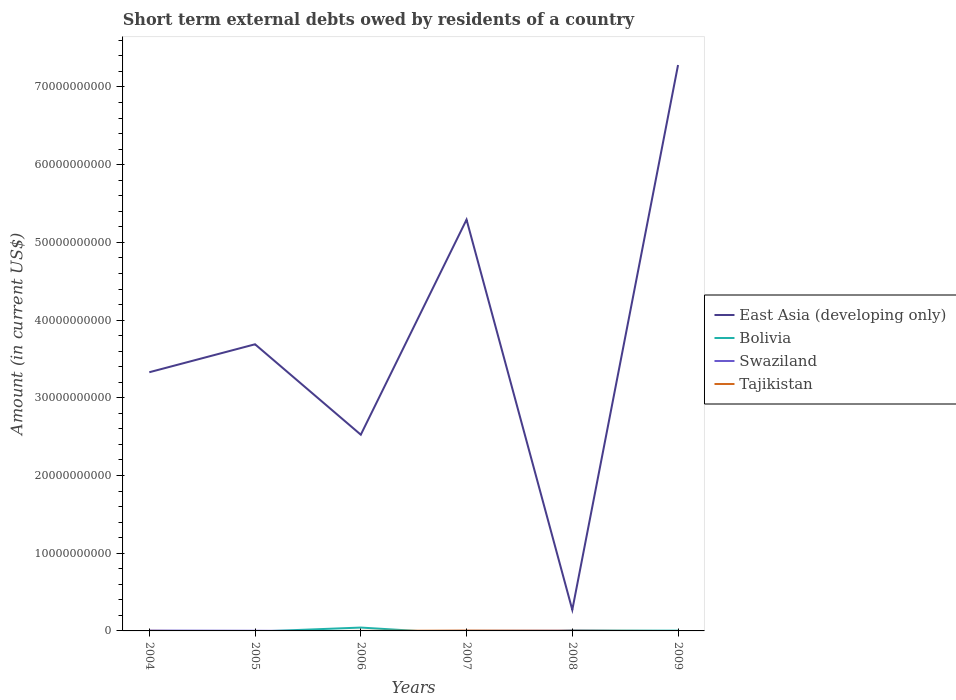What is the total amount of short-term external debts owed by residents in East Asia (developing only) in the graph?
Keep it short and to the point. -4.76e+1. What is the difference between the highest and the second highest amount of short-term external debts owed by residents in Tajikistan?
Make the answer very short. 4.32e+07. What is the difference between the highest and the lowest amount of short-term external debts owed by residents in East Asia (developing only)?
Provide a succinct answer. 2. Is the amount of short-term external debts owed by residents in East Asia (developing only) strictly greater than the amount of short-term external debts owed by residents in Tajikistan over the years?
Offer a terse response. No. How many years are there in the graph?
Provide a short and direct response. 6. Are the values on the major ticks of Y-axis written in scientific E-notation?
Your response must be concise. No. Where does the legend appear in the graph?
Provide a short and direct response. Center right. How many legend labels are there?
Your response must be concise. 4. How are the legend labels stacked?
Keep it short and to the point. Vertical. What is the title of the graph?
Your response must be concise. Short term external debts owed by residents of a country. Does "Dominica" appear as one of the legend labels in the graph?
Offer a very short reply. No. What is the Amount (in current US$) of East Asia (developing only) in 2004?
Ensure brevity in your answer.  3.33e+1. What is the Amount (in current US$) of Swaziland in 2004?
Your answer should be compact. 4.37e+07. What is the Amount (in current US$) of East Asia (developing only) in 2005?
Offer a very short reply. 3.69e+1. What is the Amount (in current US$) in Bolivia in 2005?
Give a very brief answer. 0. What is the Amount (in current US$) in Swaziland in 2005?
Offer a terse response. 2.10e+07. What is the Amount (in current US$) of East Asia (developing only) in 2006?
Ensure brevity in your answer.  2.53e+1. What is the Amount (in current US$) in Bolivia in 2006?
Offer a terse response. 4.33e+08. What is the Amount (in current US$) in Swaziland in 2006?
Your answer should be compact. 0. What is the Amount (in current US$) in Tajikistan in 2006?
Keep it short and to the point. 3.80e+06. What is the Amount (in current US$) of East Asia (developing only) in 2007?
Your response must be concise. 5.29e+1. What is the Amount (in current US$) of Bolivia in 2007?
Provide a short and direct response. 0. What is the Amount (in current US$) of Swaziland in 2007?
Ensure brevity in your answer.  0. What is the Amount (in current US$) in Tajikistan in 2007?
Your answer should be very brief. 4.32e+07. What is the Amount (in current US$) in East Asia (developing only) in 2008?
Make the answer very short. 2.72e+09. What is the Amount (in current US$) in Bolivia in 2008?
Provide a short and direct response. 4.70e+07. What is the Amount (in current US$) in Swaziland in 2008?
Offer a very short reply. 2.70e+07. What is the Amount (in current US$) in Tajikistan in 2008?
Keep it short and to the point. 1.77e+07. What is the Amount (in current US$) in East Asia (developing only) in 2009?
Your response must be concise. 7.28e+1. What is the Amount (in current US$) of Bolivia in 2009?
Give a very brief answer. 3.44e+07. What is the Amount (in current US$) in Swaziland in 2009?
Keep it short and to the point. 0. What is the Amount (in current US$) in Tajikistan in 2009?
Your answer should be very brief. 0. Across all years, what is the maximum Amount (in current US$) in East Asia (developing only)?
Offer a very short reply. 7.28e+1. Across all years, what is the maximum Amount (in current US$) of Bolivia?
Offer a very short reply. 4.33e+08. Across all years, what is the maximum Amount (in current US$) of Swaziland?
Give a very brief answer. 4.37e+07. Across all years, what is the maximum Amount (in current US$) of Tajikistan?
Provide a short and direct response. 4.32e+07. Across all years, what is the minimum Amount (in current US$) of East Asia (developing only)?
Provide a short and direct response. 2.72e+09. Across all years, what is the minimum Amount (in current US$) of Swaziland?
Your answer should be very brief. 0. Across all years, what is the minimum Amount (in current US$) of Tajikistan?
Your answer should be compact. 0. What is the total Amount (in current US$) of East Asia (developing only) in the graph?
Offer a very short reply. 2.24e+11. What is the total Amount (in current US$) in Bolivia in the graph?
Keep it short and to the point. 5.14e+08. What is the total Amount (in current US$) in Swaziland in the graph?
Give a very brief answer. 9.17e+07. What is the total Amount (in current US$) of Tajikistan in the graph?
Your answer should be very brief. 6.87e+07. What is the difference between the Amount (in current US$) of East Asia (developing only) in 2004 and that in 2005?
Provide a short and direct response. -3.60e+09. What is the difference between the Amount (in current US$) of Swaziland in 2004 and that in 2005?
Ensure brevity in your answer.  2.27e+07. What is the difference between the Amount (in current US$) in East Asia (developing only) in 2004 and that in 2006?
Keep it short and to the point. 8.04e+09. What is the difference between the Amount (in current US$) of East Asia (developing only) in 2004 and that in 2007?
Give a very brief answer. -1.96e+1. What is the difference between the Amount (in current US$) in Tajikistan in 2004 and that in 2007?
Your answer should be compact. -3.92e+07. What is the difference between the Amount (in current US$) of East Asia (developing only) in 2004 and that in 2008?
Offer a terse response. 3.06e+1. What is the difference between the Amount (in current US$) in Swaziland in 2004 and that in 2008?
Your response must be concise. 1.67e+07. What is the difference between the Amount (in current US$) in Tajikistan in 2004 and that in 2008?
Offer a very short reply. -1.37e+07. What is the difference between the Amount (in current US$) of East Asia (developing only) in 2004 and that in 2009?
Provide a short and direct response. -3.95e+1. What is the difference between the Amount (in current US$) in East Asia (developing only) in 2005 and that in 2006?
Ensure brevity in your answer.  1.16e+1. What is the difference between the Amount (in current US$) in East Asia (developing only) in 2005 and that in 2007?
Give a very brief answer. -1.60e+1. What is the difference between the Amount (in current US$) of East Asia (developing only) in 2005 and that in 2008?
Your answer should be very brief. 3.42e+1. What is the difference between the Amount (in current US$) of Swaziland in 2005 and that in 2008?
Your answer should be very brief. -6.00e+06. What is the difference between the Amount (in current US$) of East Asia (developing only) in 2005 and that in 2009?
Give a very brief answer. -3.59e+1. What is the difference between the Amount (in current US$) of East Asia (developing only) in 2006 and that in 2007?
Offer a very short reply. -2.77e+1. What is the difference between the Amount (in current US$) in Tajikistan in 2006 and that in 2007?
Give a very brief answer. -3.94e+07. What is the difference between the Amount (in current US$) in East Asia (developing only) in 2006 and that in 2008?
Your answer should be very brief. 2.25e+1. What is the difference between the Amount (in current US$) in Bolivia in 2006 and that in 2008?
Make the answer very short. 3.86e+08. What is the difference between the Amount (in current US$) of Tajikistan in 2006 and that in 2008?
Provide a short and direct response. -1.39e+07. What is the difference between the Amount (in current US$) in East Asia (developing only) in 2006 and that in 2009?
Offer a very short reply. -4.76e+1. What is the difference between the Amount (in current US$) in Bolivia in 2006 and that in 2009?
Ensure brevity in your answer.  3.99e+08. What is the difference between the Amount (in current US$) in East Asia (developing only) in 2007 and that in 2008?
Provide a succinct answer. 5.02e+1. What is the difference between the Amount (in current US$) in Tajikistan in 2007 and that in 2008?
Give a very brief answer. 2.55e+07. What is the difference between the Amount (in current US$) of East Asia (developing only) in 2007 and that in 2009?
Ensure brevity in your answer.  -1.99e+1. What is the difference between the Amount (in current US$) in East Asia (developing only) in 2008 and that in 2009?
Provide a succinct answer. -7.01e+1. What is the difference between the Amount (in current US$) in Bolivia in 2008 and that in 2009?
Your response must be concise. 1.27e+07. What is the difference between the Amount (in current US$) of East Asia (developing only) in 2004 and the Amount (in current US$) of Swaziland in 2005?
Your answer should be compact. 3.33e+1. What is the difference between the Amount (in current US$) in East Asia (developing only) in 2004 and the Amount (in current US$) in Bolivia in 2006?
Your response must be concise. 3.29e+1. What is the difference between the Amount (in current US$) of East Asia (developing only) in 2004 and the Amount (in current US$) of Tajikistan in 2006?
Your answer should be very brief. 3.33e+1. What is the difference between the Amount (in current US$) of Swaziland in 2004 and the Amount (in current US$) of Tajikistan in 2006?
Make the answer very short. 3.99e+07. What is the difference between the Amount (in current US$) of East Asia (developing only) in 2004 and the Amount (in current US$) of Tajikistan in 2007?
Your response must be concise. 3.32e+1. What is the difference between the Amount (in current US$) of Swaziland in 2004 and the Amount (in current US$) of Tajikistan in 2007?
Offer a very short reply. 5.22e+05. What is the difference between the Amount (in current US$) in East Asia (developing only) in 2004 and the Amount (in current US$) in Bolivia in 2008?
Offer a very short reply. 3.32e+1. What is the difference between the Amount (in current US$) of East Asia (developing only) in 2004 and the Amount (in current US$) of Swaziland in 2008?
Give a very brief answer. 3.33e+1. What is the difference between the Amount (in current US$) of East Asia (developing only) in 2004 and the Amount (in current US$) of Tajikistan in 2008?
Your response must be concise. 3.33e+1. What is the difference between the Amount (in current US$) of Swaziland in 2004 and the Amount (in current US$) of Tajikistan in 2008?
Your answer should be very brief. 2.60e+07. What is the difference between the Amount (in current US$) of East Asia (developing only) in 2004 and the Amount (in current US$) of Bolivia in 2009?
Make the answer very short. 3.33e+1. What is the difference between the Amount (in current US$) of East Asia (developing only) in 2005 and the Amount (in current US$) of Bolivia in 2006?
Offer a very short reply. 3.65e+1. What is the difference between the Amount (in current US$) of East Asia (developing only) in 2005 and the Amount (in current US$) of Tajikistan in 2006?
Your answer should be very brief. 3.69e+1. What is the difference between the Amount (in current US$) in Swaziland in 2005 and the Amount (in current US$) in Tajikistan in 2006?
Your answer should be compact. 1.72e+07. What is the difference between the Amount (in current US$) in East Asia (developing only) in 2005 and the Amount (in current US$) in Tajikistan in 2007?
Make the answer very short. 3.68e+1. What is the difference between the Amount (in current US$) in Swaziland in 2005 and the Amount (in current US$) in Tajikistan in 2007?
Offer a very short reply. -2.22e+07. What is the difference between the Amount (in current US$) of East Asia (developing only) in 2005 and the Amount (in current US$) of Bolivia in 2008?
Your response must be concise. 3.68e+1. What is the difference between the Amount (in current US$) of East Asia (developing only) in 2005 and the Amount (in current US$) of Swaziland in 2008?
Your answer should be very brief. 3.69e+1. What is the difference between the Amount (in current US$) of East Asia (developing only) in 2005 and the Amount (in current US$) of Tajikistan in 2008?
Offer a terse response. 3.69e+1. What is the difference between the Amount (in current US$) of Swaziland in 2005 and the Amount (in current US$) of Tajikistan in 2008?
Your response must be concise. 3.30e+06. What is the difference between the Amount (in current US$) of East Asia (developing only) in 2005 and the Amount (in current US$) of Bolivia in 2009?
Your response must be concise. 3.69e+1. What is the difference between the Amount (in current US$) in East Asia (developing only) in 2006 and the Amount (in current US$) in Tajikistan in 2007?
Your answer should be compact. 2.52e+1. What is the difference between the Amount (in current US$) in Bolivia in 2006 and the Amount (in current US$) in Tajikistan in 2007?
Keep it short and to the point. 3.90e+08. What is the difference between the Amount (in current US$) of East Asia (developing only) in 2006 and the Amount (in current US$) of Bolivia in 2008?
Ensure brevity in your answer.  2.52e+1. What is the difference between the Amount (in current US$) in East Asia (developing only) in 2006 and the Amount (in current US$) in Swaziland in 2008?
Your answer should be compact. 2.52e+1. What is the difference between the Amount (in current US$) of East Asia (developing only) in 2006 and the Amount (in current US$) of Tajikistan in 2008?
Provide a succinct answer. 2.52e+1. What is the difference between the Amount (in current US$) in Bolivia in 2006 and the Amount (in current US$) in Swaziland in 2008?
Offer a terse response. 4.06e+08. What is the difference between the Amount (in current US$) of Bolivia in 2006 and the Amount (in current US$) of Tajikistan in 2008?
Your answer should be very brief. 4.15e+08. What is the difference between the Amount (in current US$) in East Asia (developing only) in 2006 and the Amount (in current US$) in Bolivia in 2009?
Offer a very short reply. 2.52e+1. What is the difference between the Amount (in current US$) in East Asia (developing only) in 2007 and the Amount (in current US$) in Bolivia in 2008?
Your answer should be very brief. 5.29e+1. What is the difference between the Amount (in current US$) in East Asia (developing only) in 2007 and the Amount (in current US$) in Swaziland in 2008?
Give a very brief answer. 5.29e+1. What is the difference between the Amount (in current US$) in East Asia (developing only) in 2007 and the Amount (in current US$) in Tajikistan in 2008?
Your answer should be compact. 5.29e+1. What is the difference between the Amount (in current US$) in East Asia (developing only) in 2007 and the Amount (in current US$) in Bolivia in 2009?
Your answer should be very brief. 5.29e+1. What is the difference between the Amount (in current US$) in East Asia (developing only) in 2008 and the Amount (in current US$) in Bolivia in 2009?
Your answer should be compact. 2.68e+09. What is the average Amount (in current US$) in East Asia (developing only) per year?
Your answer should be very brief. 3.73e+1. What is the average Amount (in current US$) of Bolivia per year?
Make the answer very short. 8.57e+07. What is the average Amount (in current US$) of Swaziland per year?
Your response must be concise. 1.53e+07. What is the average Amount (in current US$) in Tajikistan per year?
Make the answer very short. 1.14e+07. In the year 2004, what is the difference between the Amount (in current US$) in East Asia (developing only) and Amount (in current US$) in Swaziland?
Offer a terse response. 3.32e+1. In the year 2004, what is the difference between the Amount (in current US$) of East Asia (developing only) and Amount (in current US$) of Tajikistan?
Provide a succinct answer. 3.33e+1. In the year 2004, what is the difference between the Amount (in current US$) in Swaziland and Amount (in current US$) in Tajikistan?
Provide a succinct answer. 3.97e+07. In the year 2005, what is the difference between the Amount (in current US$) of East Asia (developing only) and Amount (in current US$) of Swaziland?
Offer a terse response. 3.69e+1. In the year 2006, what is the difference between the Amount (in current US$) in East Asia (developing only) and Amount (in current US$) in Bolivia?
Keep it short and to the point. 2.48e+1. In the year 2006, what is the difference between the Amount (in current US$) of East Asia (developing only) and Amount (in current US$) of Tajikistan?
Your response must be concise. 2.52e+1. In the year 2006, what is the difference between the Amount (in current US$) of Bolivia and Amount (in current US$) of Tajikistan?
Ensure brevity in your answer.  4.29e+08. In the year 2007, what is the difference between the Amount (in current US$) of East Asia (developing only) and Amount (in current US$) of Tajikistan?
Offer a terse response. 5.29e+1. In the year 2008, what is the difference between the Amount (in current US$) of East Asia (developing only) and Amount (in current US$) of Bolivia?
Keep it short and to the point. 2.67e+09. In the year 2008, what is the difference between the Amount (in current US$) in East Asia (developing only) and Amount (in current US$) in Swaziland?
Keep it short and to the point. 2.69e+09. In the year 2008, what is the difference between the Amount (in current US$) in East Asia (developing only) and Amount (in current US$) in Tajikistan?
Ensure brevity in your answer.  2.70e+09. In the year 2008, what is the difference between the Amount (in current US$) of Bolivia and Amount (in current US$) of Swaziland?
Offer a very short reply. 2.00e+07. In the year 2008, what is the difference between the Amount (in current US$) of Bolivia and Amount (in current US$) of Tajikistan?
Your answer should be compact. 2.93e+07. In the year 2008, what is the difference between the Amount (in current US$) in Swaziland and Amount (in current US$) in Tajikistan?
Offer a very short reply. 9.30e+06. In the year 2009, what is the difference between the Amount (in current US$) in East Asia (developing only) and Amount (in current US$) in Bolivia?
Provide a succinct answer. 7.28e+1. What is the ratio of the Amount (in current US$) of East Asia (developing only) in 2004 to that in 2005?
Make the answer very short. 0.9. What is the ratio of the Amount (in current US$) of Swaziland in 2004 to that in 2005?
Offer a very short reply. 2.08. What is the ratio of the Amount (in current US$) of East Asia (developing only) in 2004 to that in 2006?
Provide a short and direct response. 1.32. What is the ratio of the Amount (in current US$) in Tajikistan in 2004 to that in 2006?
Your response must be concise. 1.05. What is the ratio of the Amount (in current US$) of East Asia (developing only) in 2004 to that in 2007?
Your answer should be very brief. 0.63. What is the ratio of the Amount (in current US$) in Tajikistan in 2004 to that in 2007?
Your response must be concise. 0.09. What is the ratio of the Amount (in current US$) of East Asia (developing only) in 2004 to that in 2008?
Provide a short and direct response. 12.26. What is the ratio of the Amount (in current US$) of Swaziland in 2004 to that in 2008?
Your answer should be compact. 1.62. What is the ratio of the Amount (in current US$) of Tajikistan in 2004 to that in 2008?
Keep it short and to the point. 0.23. What is the ratio of the Amount (in current US$) in East Asia (developing only) in 2004 to that in 2009?
Your answer should be compact. 0.46. What is the ratio of the Amount (in current US$) in East Asia (developing only) in 2005 to that in 2006?
Provide a short and direct response. 1.46. What is the ratio of the Amount (in current US$) of East Asia (developing only) in 2005 to that in 2007?
Your answer should be very brief. 0.7. What is the ratio of the Amount (in current US$) of East Asia (developing only) in 2005 to that in 2008?
Make the answer very short. 13.59. What is the ratio of the Amount (in current US$) of Swaziland in 2005 to that in 2008?
Your answer should be compact. 0.78. What is the ratio of the Amount (in current US$) in East Asia (developing only) in 2005 to that in 2009?
Offer a very short reply. 0.51. What is the ratio of the Amount (in current US$) of East Asia (developing only) in 2006 to that in 2007?
Provide a succinct answer. 0.48. What is the ratio of the Amount (in current US$) in Tajikistan in 2006 to that in 2007?
Offer a very short reply. 0.09. What is the ratio of the Amount (in current US$) in East Asia (developing only) in 2006 to that in 2008?
Your answer should be very brief. 9.3. What is the ratio of the Amount (in current US$) in Bolivia in 2006 to that in 2008?
Give a very brief answer. 9.21. What is the ratio of the Amount (in current US$) in Tajikistan in 2006 to that in 2008?
Make the answer very short. 0.21. What is the ratio of the Amount (in current US$) in East Asia (developing only) in 2006 to that in 2009?
Give a very brief answer. 0.35. What is the ratio of the Amount (in current US$) of Bolivia in 2006 to that in 2009?
Offer a terse response. 12.6. What is the ratio of the Amount (in current US$) in East Asia (developing only) in 2007 to that in 2008?
Your answer should be compact. 19.49. What is the ratio of the Amount (in current US$) of Tajikistan in 2007 to that in 2008?
Provide a succinct answer. 2.44. What is the ratio of the Amount (in current US$) of East Asia (developing only) in 2007 to that in 2009?
Offer a very short reply. 0.73. What is the ratio of the Amount (in current US$) of East Asia (developing only) in 2008 to that in 2009?
Your answer should be very brief. 0.04. What is the ratio of the Amount (in current US$) in Bolivia in 2008 to that in 2009?
Your answer should be compact. 1.37. What is the difference between the highest and the second highest Amount (in current US$) in East Asia (developing only)?
Your response must be concise. 1.99e+1. What is the difference between the highest and the second highest Amount (in current US$) in Bolivia?
Ensure brevity in your answer.  3.86e+08. What is the difference between the highest and the second highest Amount (in current US$) in Swaziland?
Your answer should be very brief. 1.67e+07. What is the difference between the highest and the second highest Amount (in current US$) in Tajikistan?
Your answer should be very brief. 2.55e+07. What is the difference between the highest and the lowest Amount (in current US$) of East Asia (developing only)?
Give a very brief answer. 7.01e+1. What is the difference between the highest and the lowest Amount (in current US$) in Bolivia?
Your answer should be very brief. 4.33e+08. What is the difference between the highest and the lowest Amount (in current US$) in Swaziland?
Offer a very short reply. 4.37e+07. What is the difference between the highest and the lowest Amount (in current US$) in Tajikistan?
Provide a succinct answer. 4.32e+07. 